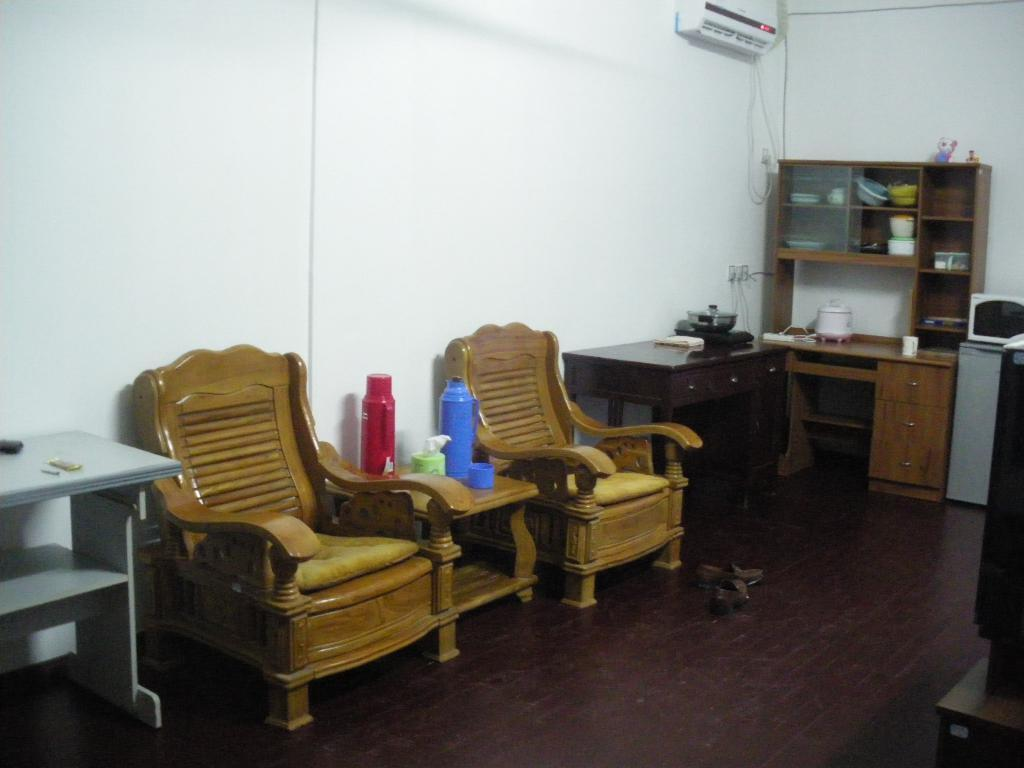What furniture items are on the left side of the image? There are two chairs, tables, and cupboards on the left side of the image. What objects can be seen on the left side of the image? There are bottles, vessels, an air conditioner, shelves, and a wall on the left side of the image. What is on the floor on the left side of the image? There is a floor on the left side of the image. What appliance is on the right side of the image? There is a microwave oven on the right side of the image. What furniture item is on the right side of the image? There is a table on the right side of the image. How many sheep are visible in the image? There are no sheep present in the image. What news is being reported on the wall in the image? There is no news being reported in the image; it only contains furniture, appliances, and other objects. 